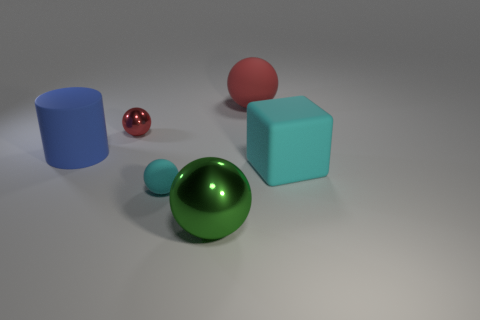Add 2 green rubber cylinders. How many objects exist? 8 Subtract all large matte spheres. How many spheres are left? 3 Subtract all cyan spheres. How many spheres are left? 3 Subtract all cubes. How many objects are left? 5 Subtract 1 cylinders. How many cylinders are left? 0 Subtract all red blocks. Subtract all purple cylinders. How many blocks are left? 1 Subtract all brown cylinders. How many purple balls are left? 0 Subtract all large yellow shiny balls. Subtract all tiny things. How many objects are left? 4 Add 4 large rubber objects. How many large rubber objects are left? 7 Add 3 small objects. How many small objects exist? 5 